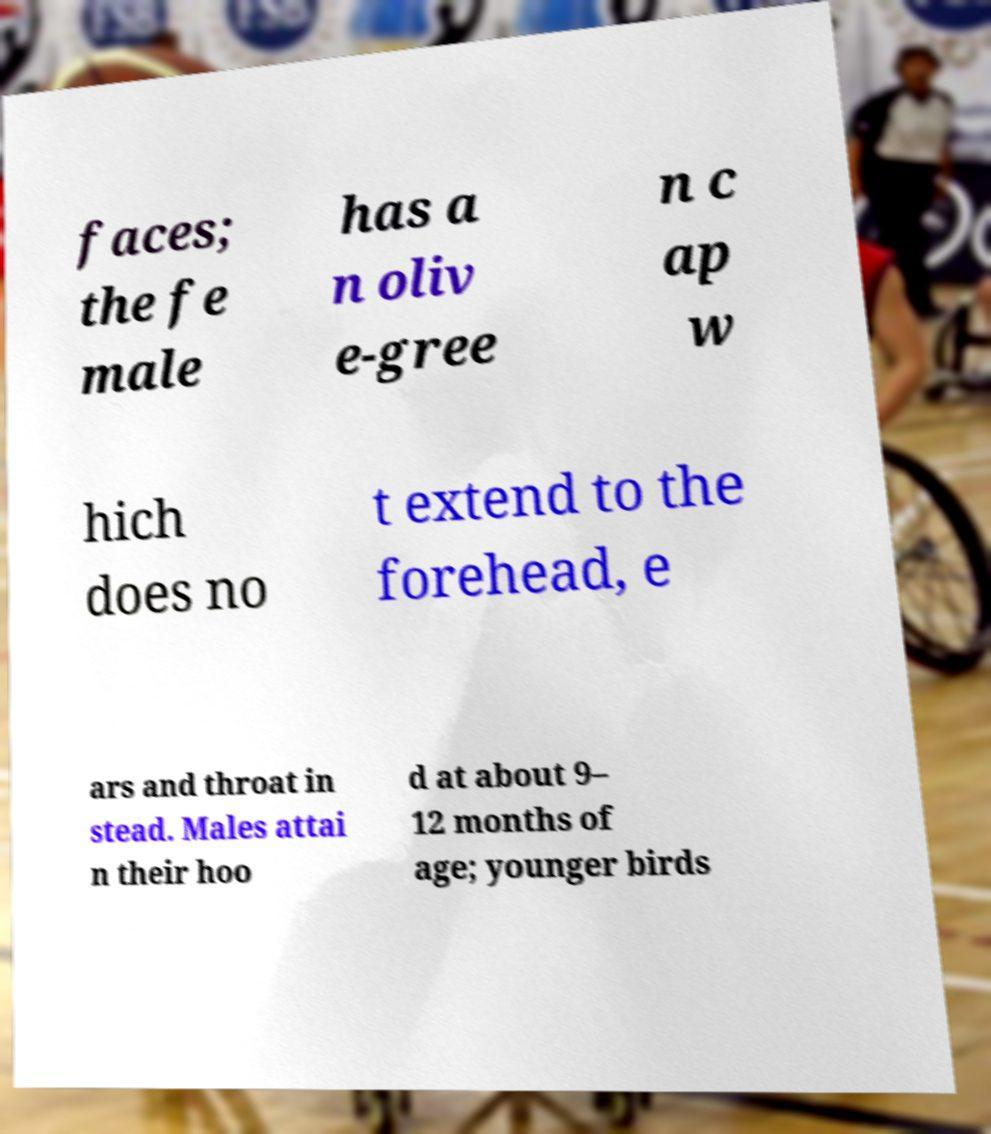What messages or text are displayed in this image? I need them in a readable, typed format. faces; the fe male has a n oliv e-gree n c ap w hich does no t extend to the forehead, e ars and throat in stead. Males attai n their hoo d at about 9– 12 months of age; younger birds 